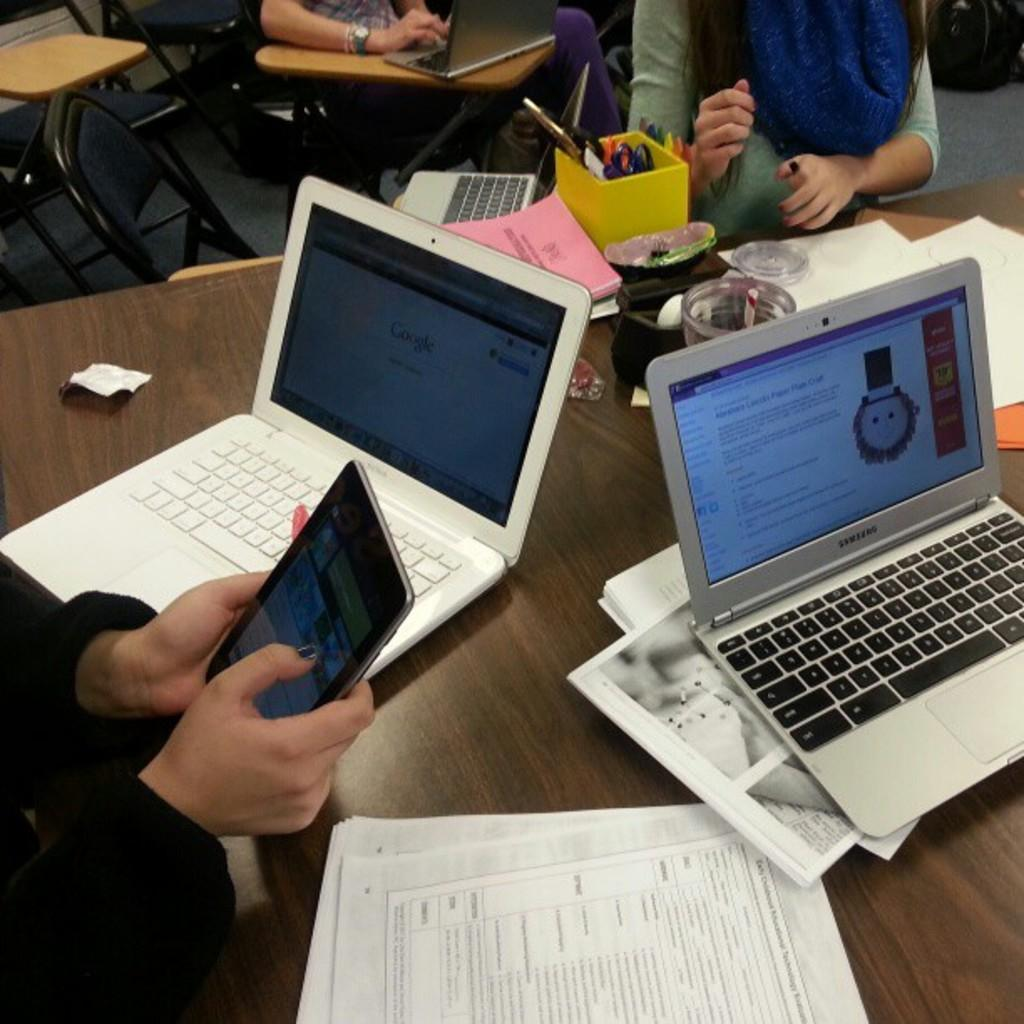What is the person in the image doing? The person is sitting on a chair in the image. What is the person holding in the image? The person is holding an electronic gadget. How many wrens can be seen flying around the person in the image? There are no wrens present in the image. What day of the week is it in the image? The day of the week is not mentioned or visible in the image. 